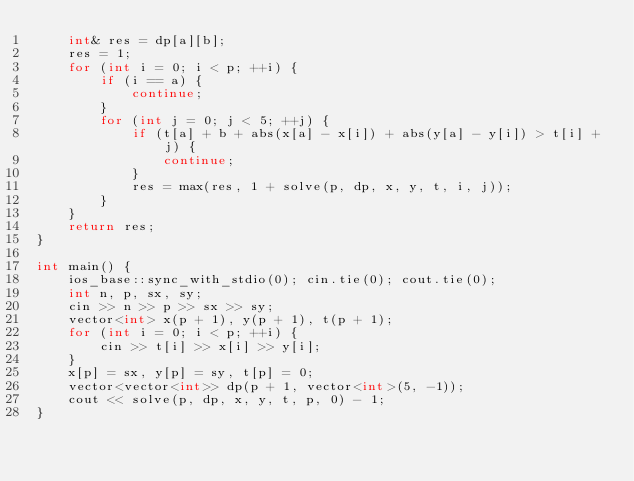Convert code to text. <code><loc_0><loc_0><loc_500><loc_500><_C++_>    int& res = dp[a][b];
    res = 1;
    for (int i = 0; i < p; ++i) {
        if (i == a) {
            continue;
        }
        for (int j = 0; j < 5; ++j) {
            if (t[a] + b + abs(x[a] - x[i]) + abs(y[a] - y[i]) > t[i] + j) {
                continue;
            }
            res = max(res, 1 + solve(p, dp, x, y, t, i, j));
        }
    }
    return res;
}

int main() {
    ios_base::sync_with_stdio(0); cin.tie(0); cout.tie(0);
    int n, p, sx, sy;
    cin >> n >> p >> sx >> sy;
    vector<int> x(p + 1), y(p + 1), t(p + 1);
    for (int i = 0; i < p; ++i) {
        cin >> t[i] >> x[i] >> y[i];
    }
    x[p] = sx, y[p] = sy, t[p] = 0;
    vector<vector<int>> dp(p + 1, vector<int>(5, -1));
    cout << solve(p, dp, x, y, t, p, 0) - 1;
}
</code> 